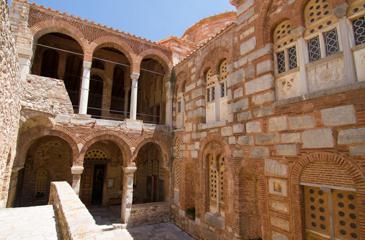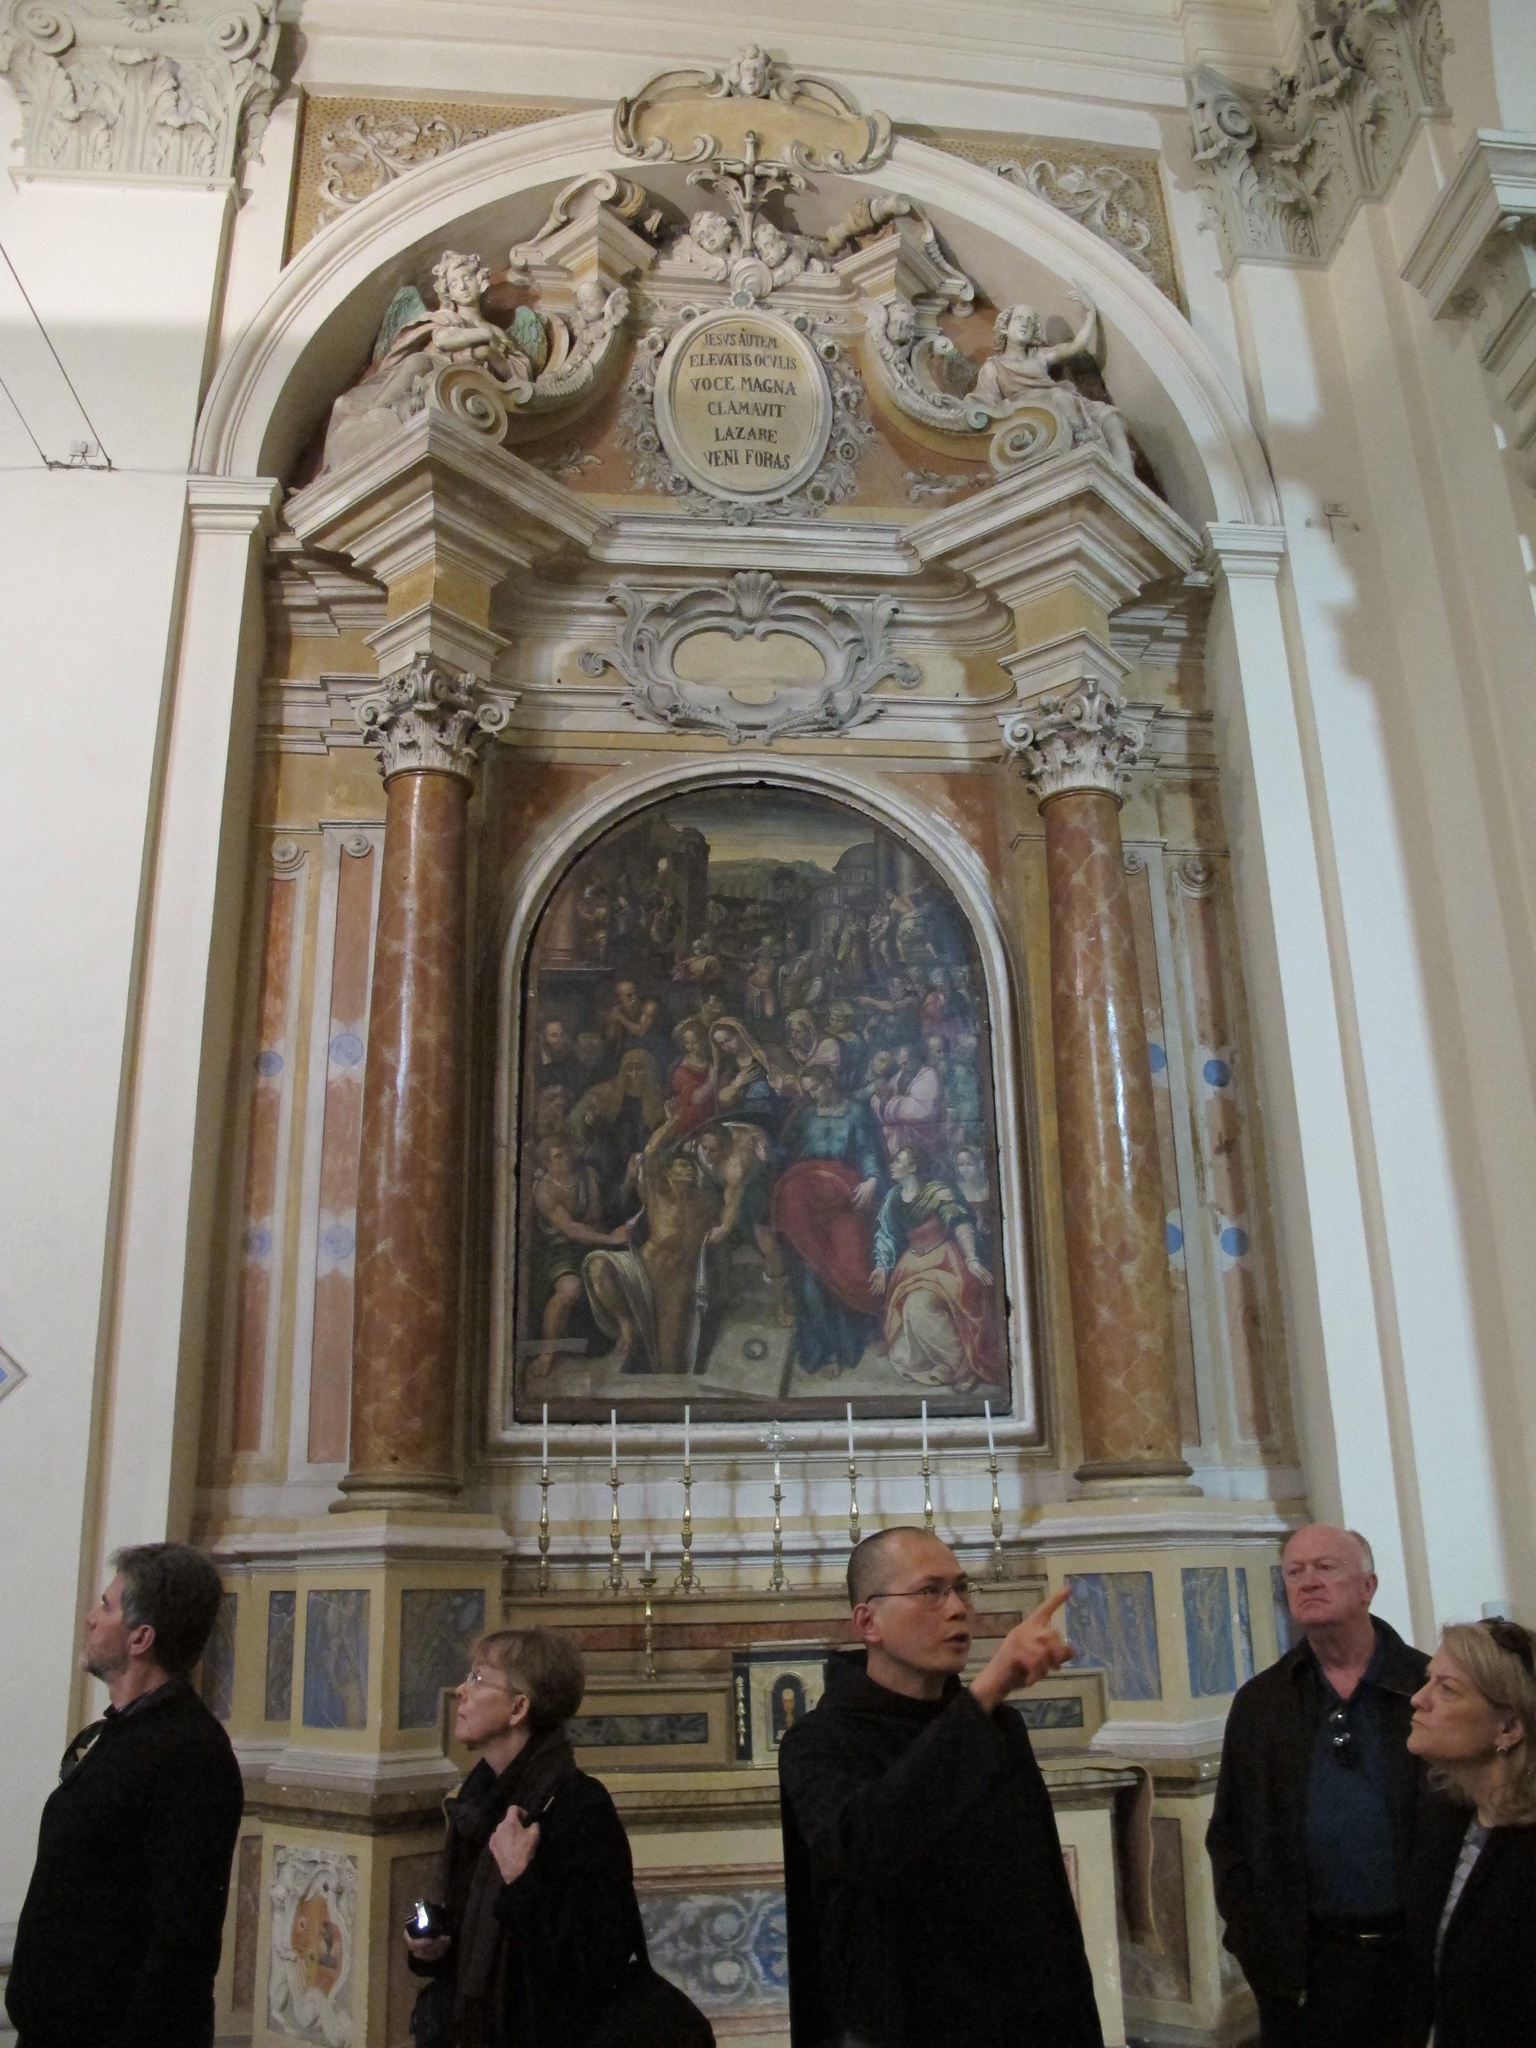The first image is the image on the left, the second image is the image on the right. Examine the images to the left and right. Is the description "more then six arches can be seen in the left photo" accurate? Answer yes or no. Yes. The first image is the image on the left, the second image is the image on the right. Examine the images to the left and right. Is the description "In at least one image there are one or more paintings." accurate? Answer yes or no. Yes. 